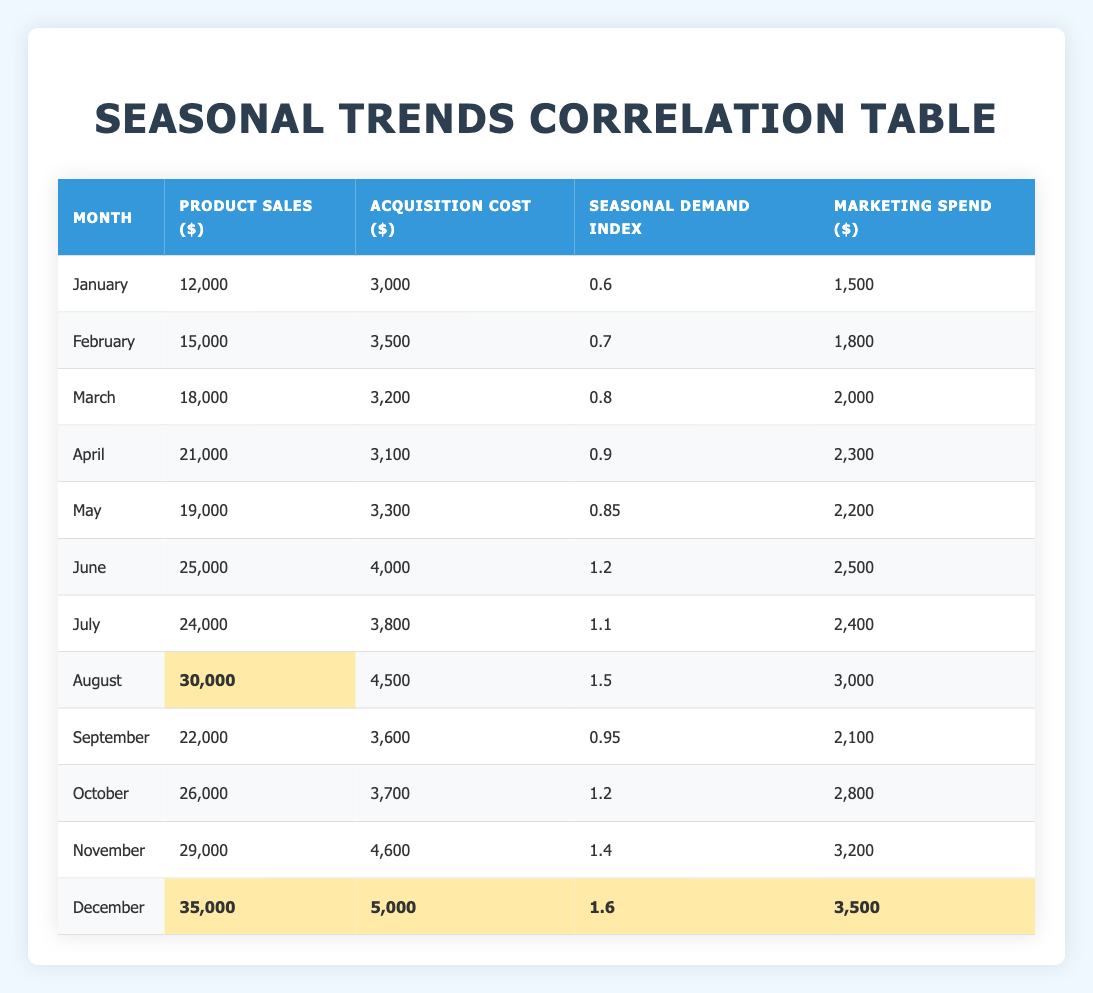What is the product sales amount in December? The table lists December with a product sales amount of 35,000.
Answer: 35,000 Which month had the highest acquisition cost? By reviewing the acquisition cost values in the table, December has the highest cost at 5,000.
Answer: 5,000 What is the average product sales from January to April? The total product sales for January (12,000), February (15,000), March (18,000), and April (21,000) is 66,000. The average is 66,000 divided by 4, which is 16,500.
Answer: 16,500 Did the seasonal demand index increase from January to December? The seasonal demand index in January is 0.6 and in December is 1.6. This indicates an increase throughout the year.
Answer: Yes What is the difference in product sales between August and January? August product sales is 30,000 and January product sales is 12,000. The difference is 30,000 minus 12,000, resulting in 18,000.
Answer: 18,000 Which month had a seasonal demand index greater than 1? The months with a seasonal demand index greater than 1 are June (1.2), August (1.5), October (1.2), November (1.4), and December (1.6).
Answer: June, August, October, November, December What is the total marketing spend for the first half of the year (January to June)? The marketing spends are 1,500 (January), 1,800 (February), 2,000 (March), 2,300 (April), 2,200 (May), 2,500 (June). Summing these amounts gives 12,300.
Answer: 12,300 Which month had the highest product sales and what was the amount? From the table, December shows the highest product sales amount of 35,000.
Answer: 35,000 What is the seasonal demand index for May and how does it compare to June? May's seasonal demand index is 0.85, while June's is 1.2. June's index is higher by 0.35.
Answer: 0.85, June's index is higher by 0.35 